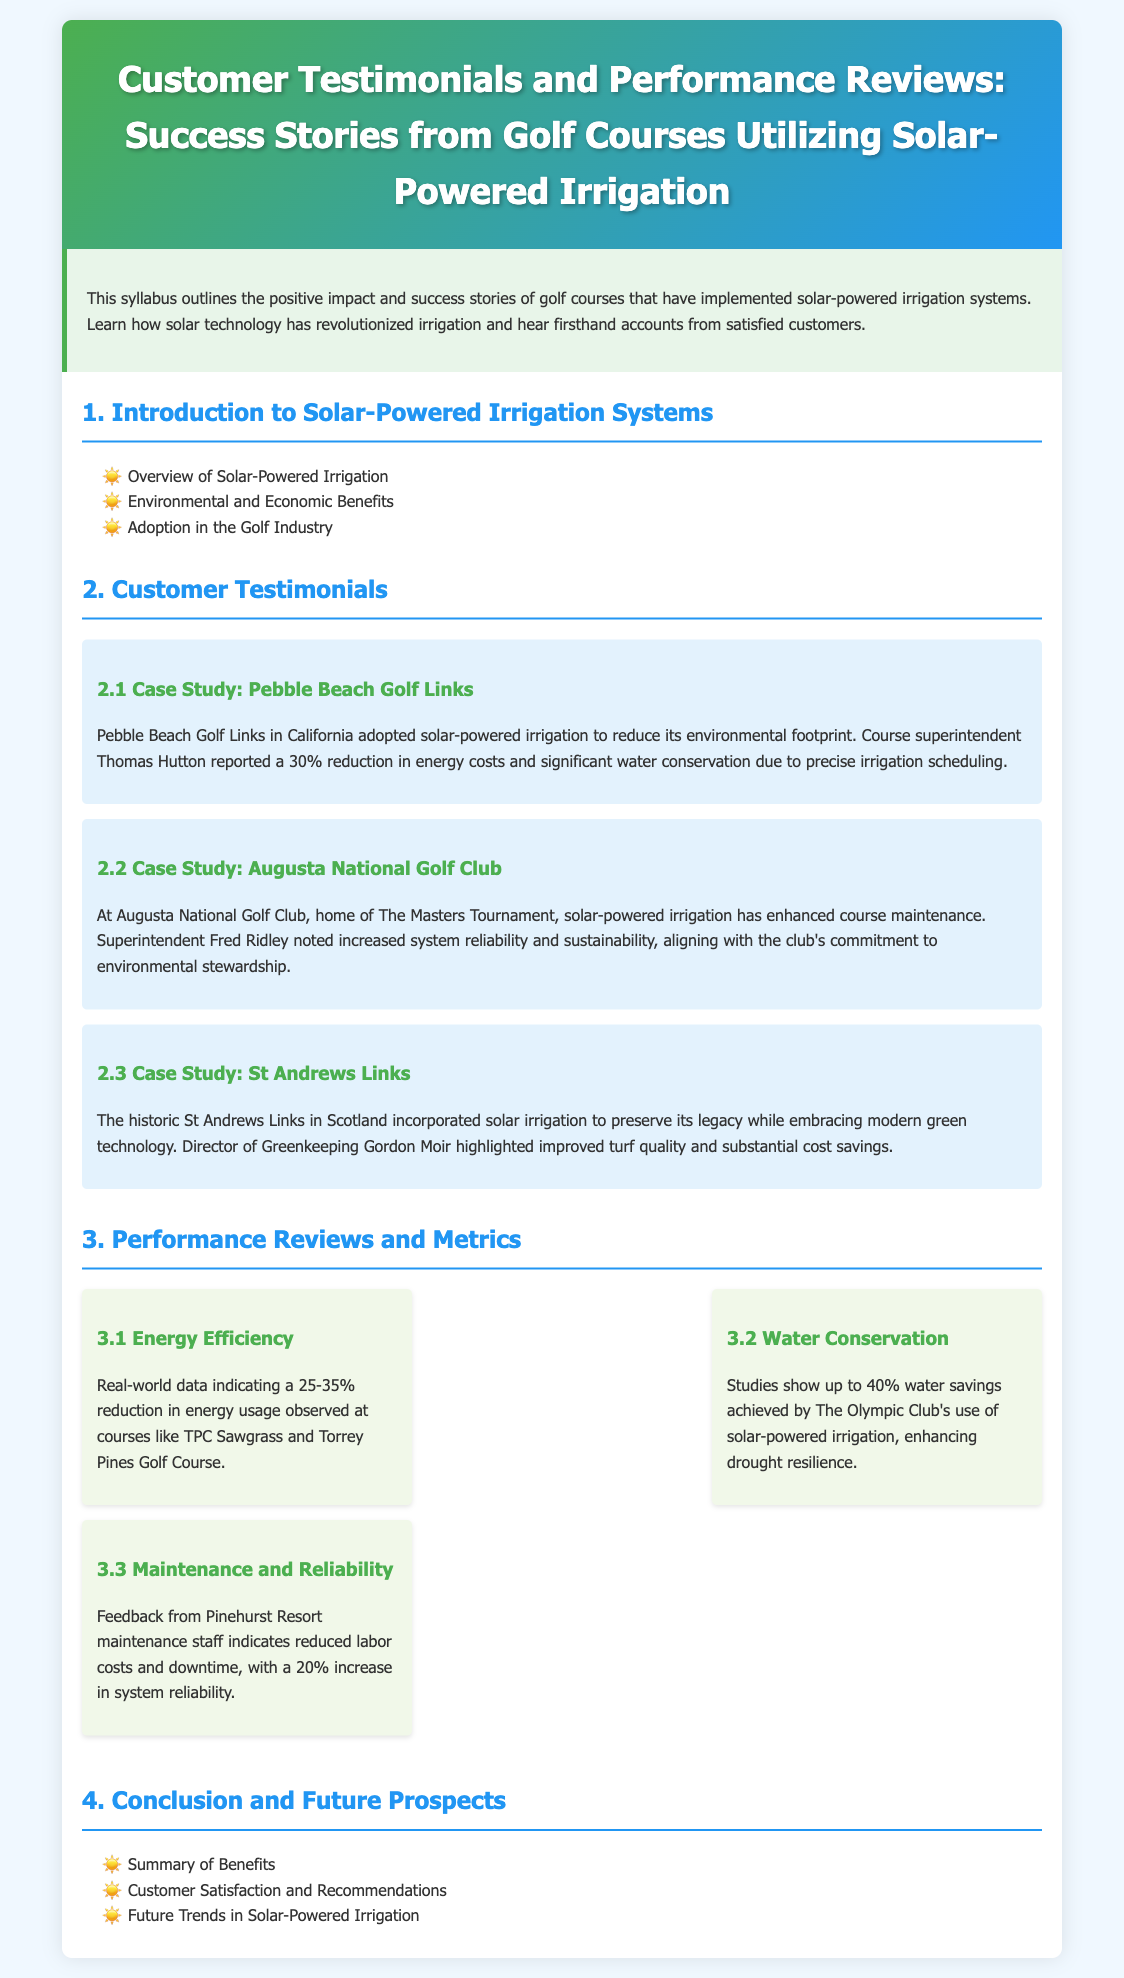What is the title of the syllabus? The title of the syllabus is stated in the header of the document.
Answer: Customer Testimonials and Performance Reviews: Success Stories from Golf Courses Utilizing Solar-Powered Irrigation Who reported a 30% reduction in energy costs? This information is found in the customer testimonials section.
Answer: Thomas Hutton What percentage of water savings did The Olympic Club achieve? This information is provided in the performance reviews and metrics section.
Answer: 40% Which golf course is mentioned as home of The Masters Tournament? This detail can be found in the case studies of customer testimonials.
Answer: Augusta National Golf Club What improvement did Gordon Moir highlight regarding turf quality? This information is specific to the case study of St Andrews Links in the customer testimonials section.
Answer: Improved turf quality What increase in system reliability was reported by maintenance staff at Pinehurst Resort? This metric is discussed in the performance reviews and metrics section.
Answer: 20% 